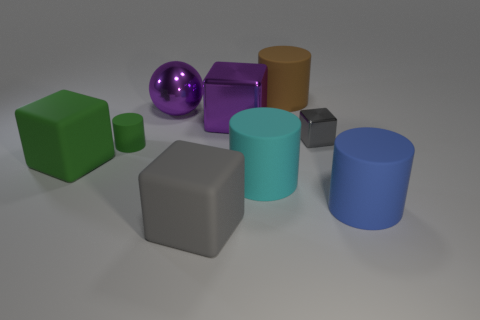Subtract all red balls. How many gray blocks are left? 2 Subtract all purple metallic cubes. How many cubes are left? 3 Add 1 things. How many objects exist? 10 Subtract 1 cylinders. How many cylinders are left? 3 Subtract all green blocks. How many blocks are left? 3 Subtract all cylinders. How many objects are left? 5 Subtract 0 brown balls. How many objects are left? 9 Subtract all cyan cubes. Subtract all green cylinders. How many cubes are left? 4 Subtract all tiny red metal spheres. Subtract all large matte cylinders. How many objects are left? 6 Add 6 purple metallic balls. How many purple metallic balls are left? 7 